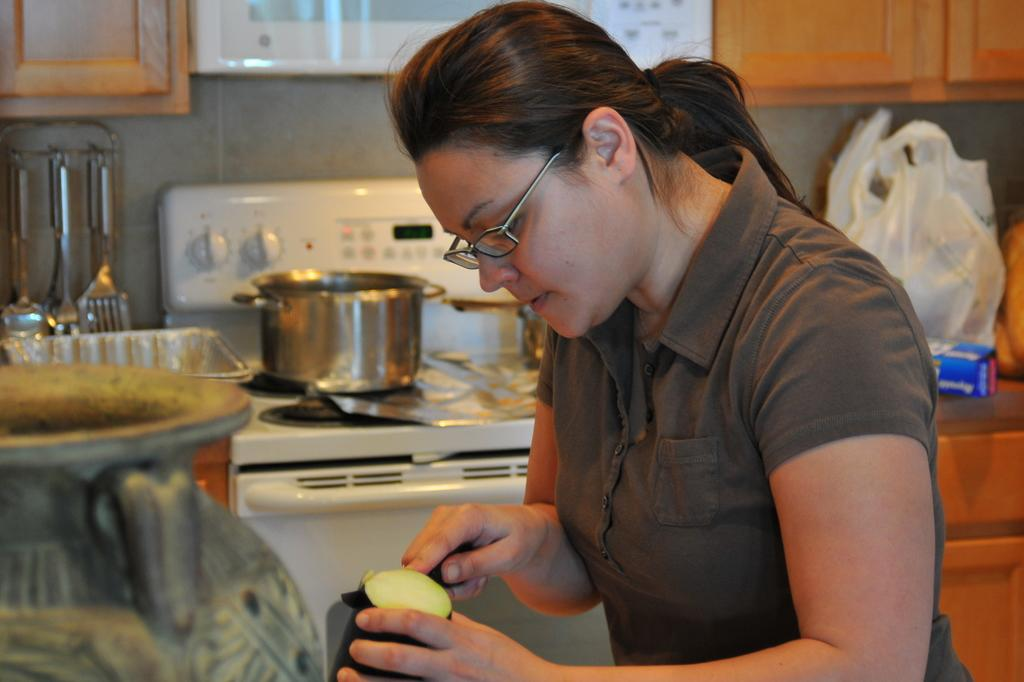What type of room is shown in the image? The image depicts a kitchen. What appliance can be seen on a platform in the kitchen? There is a stove on a platform in the image. What activity is the woman in the image engaged in? The woman is slicing vegetables in the center of the image. What type of whistle is the woman using to slice the vegetables in the image? There is no whistle present in the image; the woman is using a knife to slice the vegetables. 